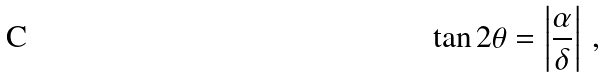<formula> <loc_0><loc_0><loc_500><loc_500>\tan 2 \theta = \left | \frac { \alpha } { \delta } \right | \, ,</formula> 